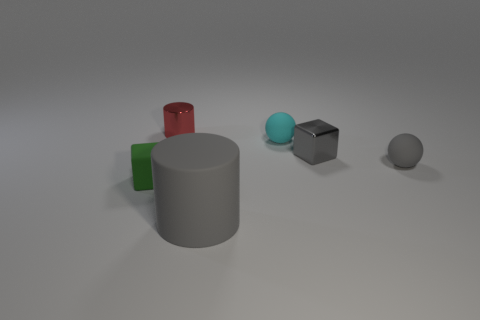Add 2 red shiny objects. How many objects exist? 8 Subtract all balls. How many objects are left? 4 Subtract all small yellow matte spheres. Subtract all big objects. How many objects are left? 5 Add 5 tiny metal cylinders. How many tiny metal cylinders are left? 6 Add 3 tiny cubes. How many tiny cubes exist? 5 Subtract 0 purple blocks. How many objects are left? 6 